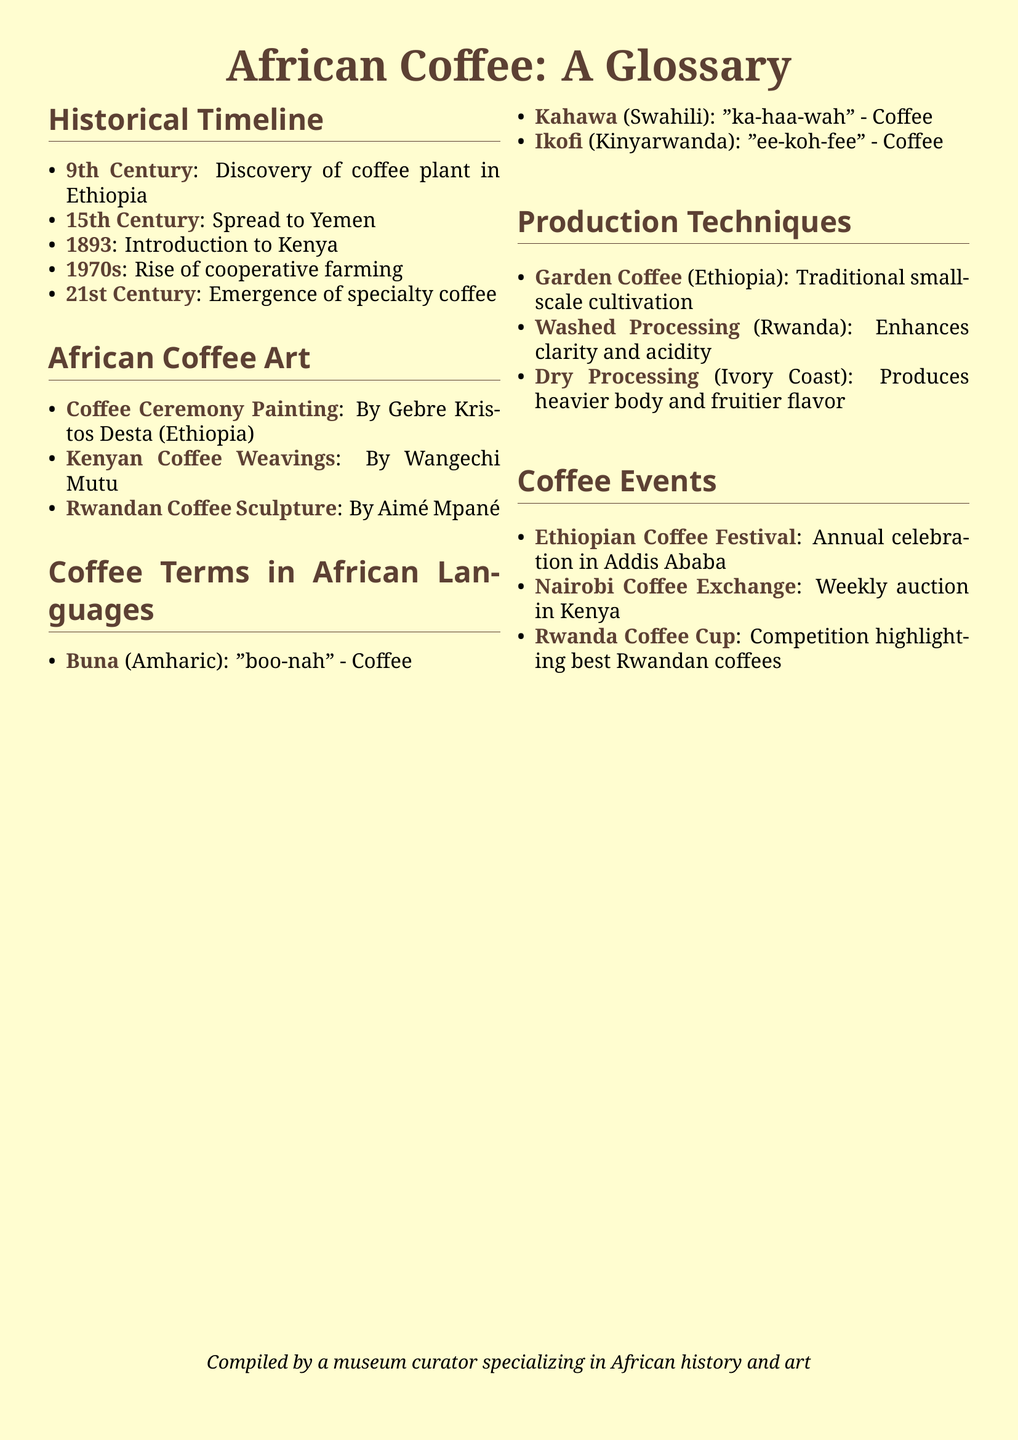What is the first recorded discovery of the coffee plant? The glossary states that the discovery of coffee plant in Ethiopia occurred in the 9th century.
Answer: 9th Century Which country introduced coffee in 1893? The document mentions that coffee was introduced to Kenya in 1893.
Answer: Kenya What is the term for coffee in Amharic? The glossary provides the term "Buna" for coffee in Amharic.
Answer: Buna Who is the artist of the Coffee Ceremony Painting? According to the document, the artist is Gebre Kristos Desta from Ethiopia.
Answer: Gebre Kristos Desta What type of coffee processing enhances clarity and acidity? The document specifies that Washed Processing (Rwanda) enhances clarity and acidity.
Answer: Washed Processing In which city is the Ethiopian Coffee Festival held? The glossary indicates that the Ethiopian Coffee Festival takes place in Addis Ababa.
Answer: Addis Ababa What significant farming trend arose in the 1970s? The document states that the rise of cooperative farming began in the 1970s.
Answer: Cooperative farming Which technique is used in traditional small-scale coffee cultivation in Ethiopia? The glossary refers to Garden Coffee as the technique used for traditional small-scale cultivation in Ethiopia.
Answer: Garden Coffee What is the phonetic transcription of coffee in Swahili? The document includes the phonetic transcription "ka-haa-wah" for coffee in Swahili.
Answer: ka-haa-wah 